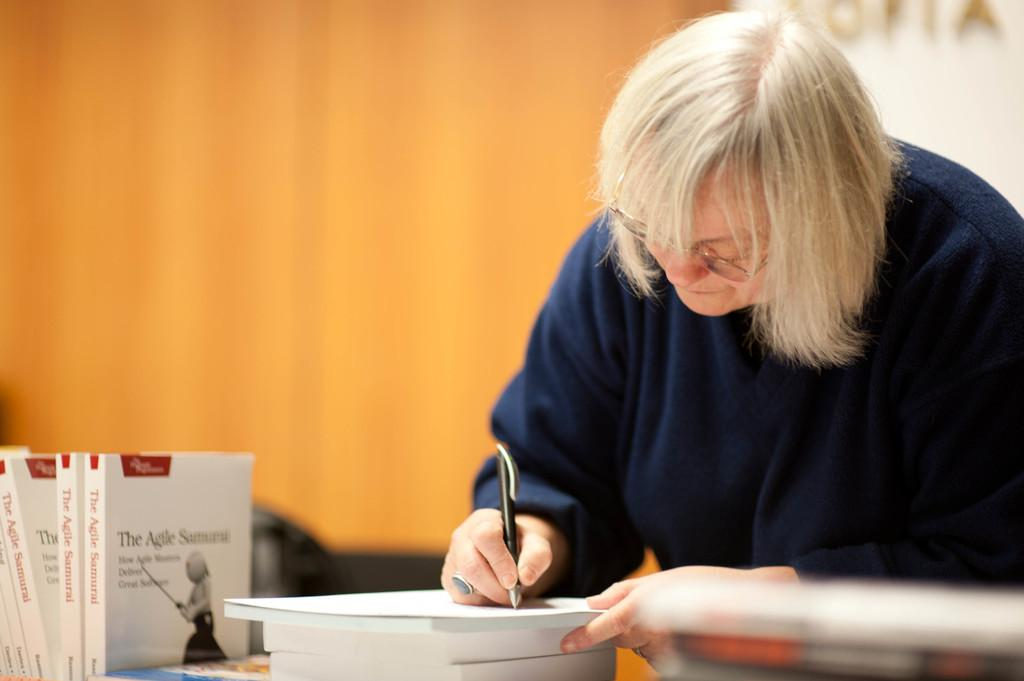<image>
Provide a brief description of the given image. A blonde woman is using a pen and standing near several copies of a book called "The Agile Samurai". 